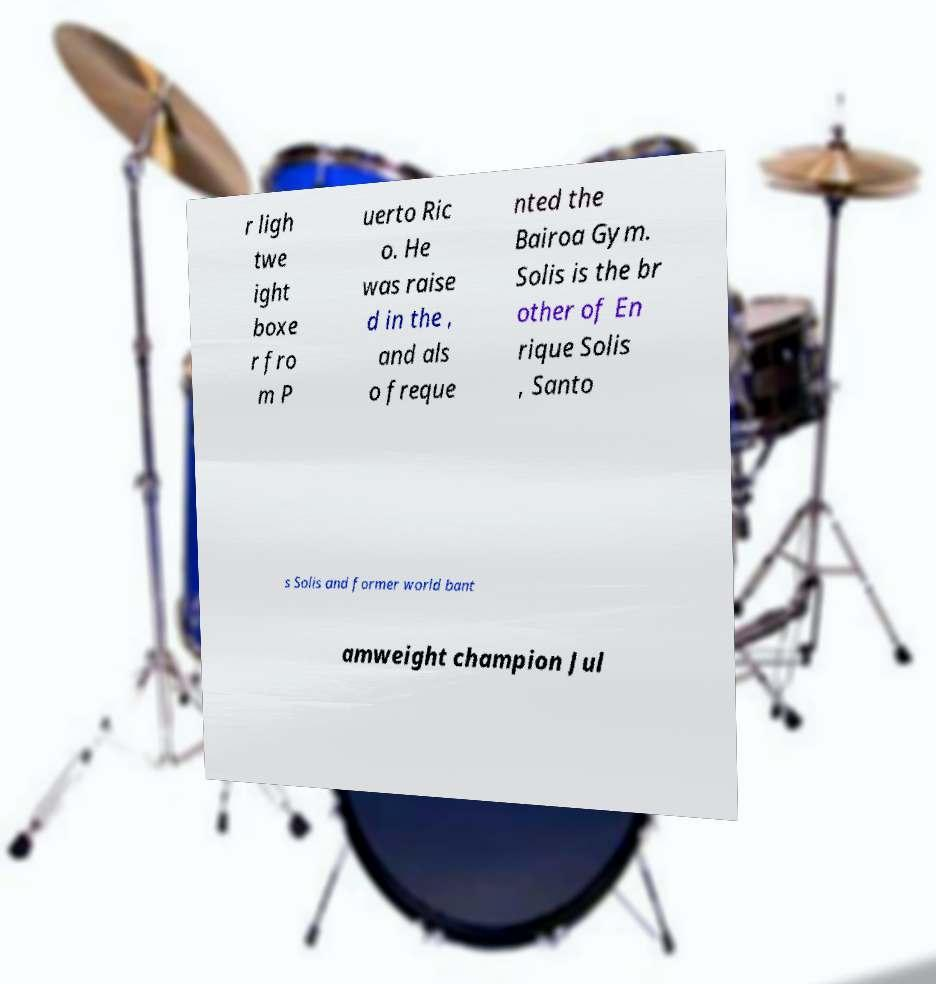Can you read and provide the text displayed in the image?This photo seems to have some interesting text. Can you extract and type it out for me? r ligh twe ight boxe r fro m P uerto Ric o. He was raise d in the , and als o freque nted the Bairoa Gym. Solis is the br other of En rique Solis , Santo s Solis and former world bant amweight champion Jul 